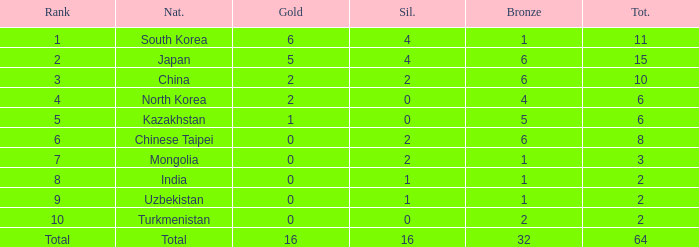How many Golds did Rank 10 get, with a Bronze larger than 2? 0.0. 